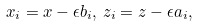<formula> <loc_0><loc_0><loc_500><loc_500>x _ { i } = x - \epsilon b _ { i } , \, z _ { i } = z - \epsilon a _ { i } ,</formula> 